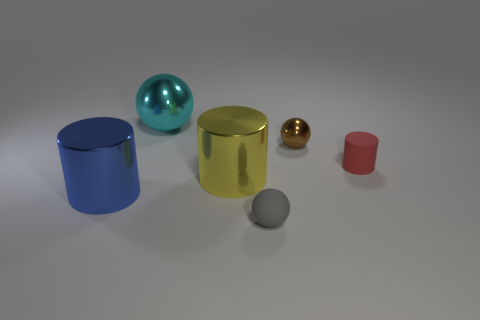What is the shape of the rubber thing behind the large yellow cylinder?
Give a very brief answer. Cylinder. Is there a blue object of the same size as the yellow object?
Give a very brief answer. Yes. Are the small ball behind the gray sphere and the large blue cylinder made of the same material?
Your answer should be very brief. Yes. Is the number of red cylinders that are behind the brown thing the same as the number of large spheres in front of the small cylinder?
Your answer should be very brief. Yes. The tiny thing that is behind the large yellow thing and in front of the small brown shiny ball has what shape?
Make the answer very short. Cylinder. There is a gray rubber object; how many large cyan metal objects are to the right of it?
Make the answer very short. 0. How many other things are the same shape as the large yellow thing?
Make the answer very short. 2. Is the number of blue shiny cylinders less than the number of rubber objects?
Offer a very short reply. Yes. There is a ball that is left of the small shiny thing and to the right of the cyan shiny ball; what is its size?
Provide a short and direct response. Small. There is a brown thing that is behind the big thing left of the shiny sphere on the left side of the small brown metal thing; what size is it?
Provide a short and direct response. Small. 